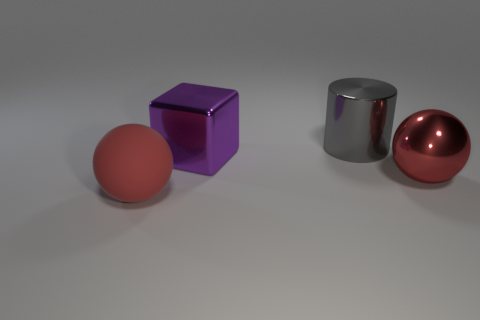Add 2 tiny purple spheres. How many objects exist? 6 Subtract all cylinders. How many objects are left? 3 Add 1 gray metallic objects. How many gray metallic objects are left? 2 Add 3 big purple objects. How many big purple objects exist? 4 Subtract 0 purple cylinders. How many objects are left? 4 Subtract all red things. Subtract all large blue rubber balls. How many objects are left? 2 